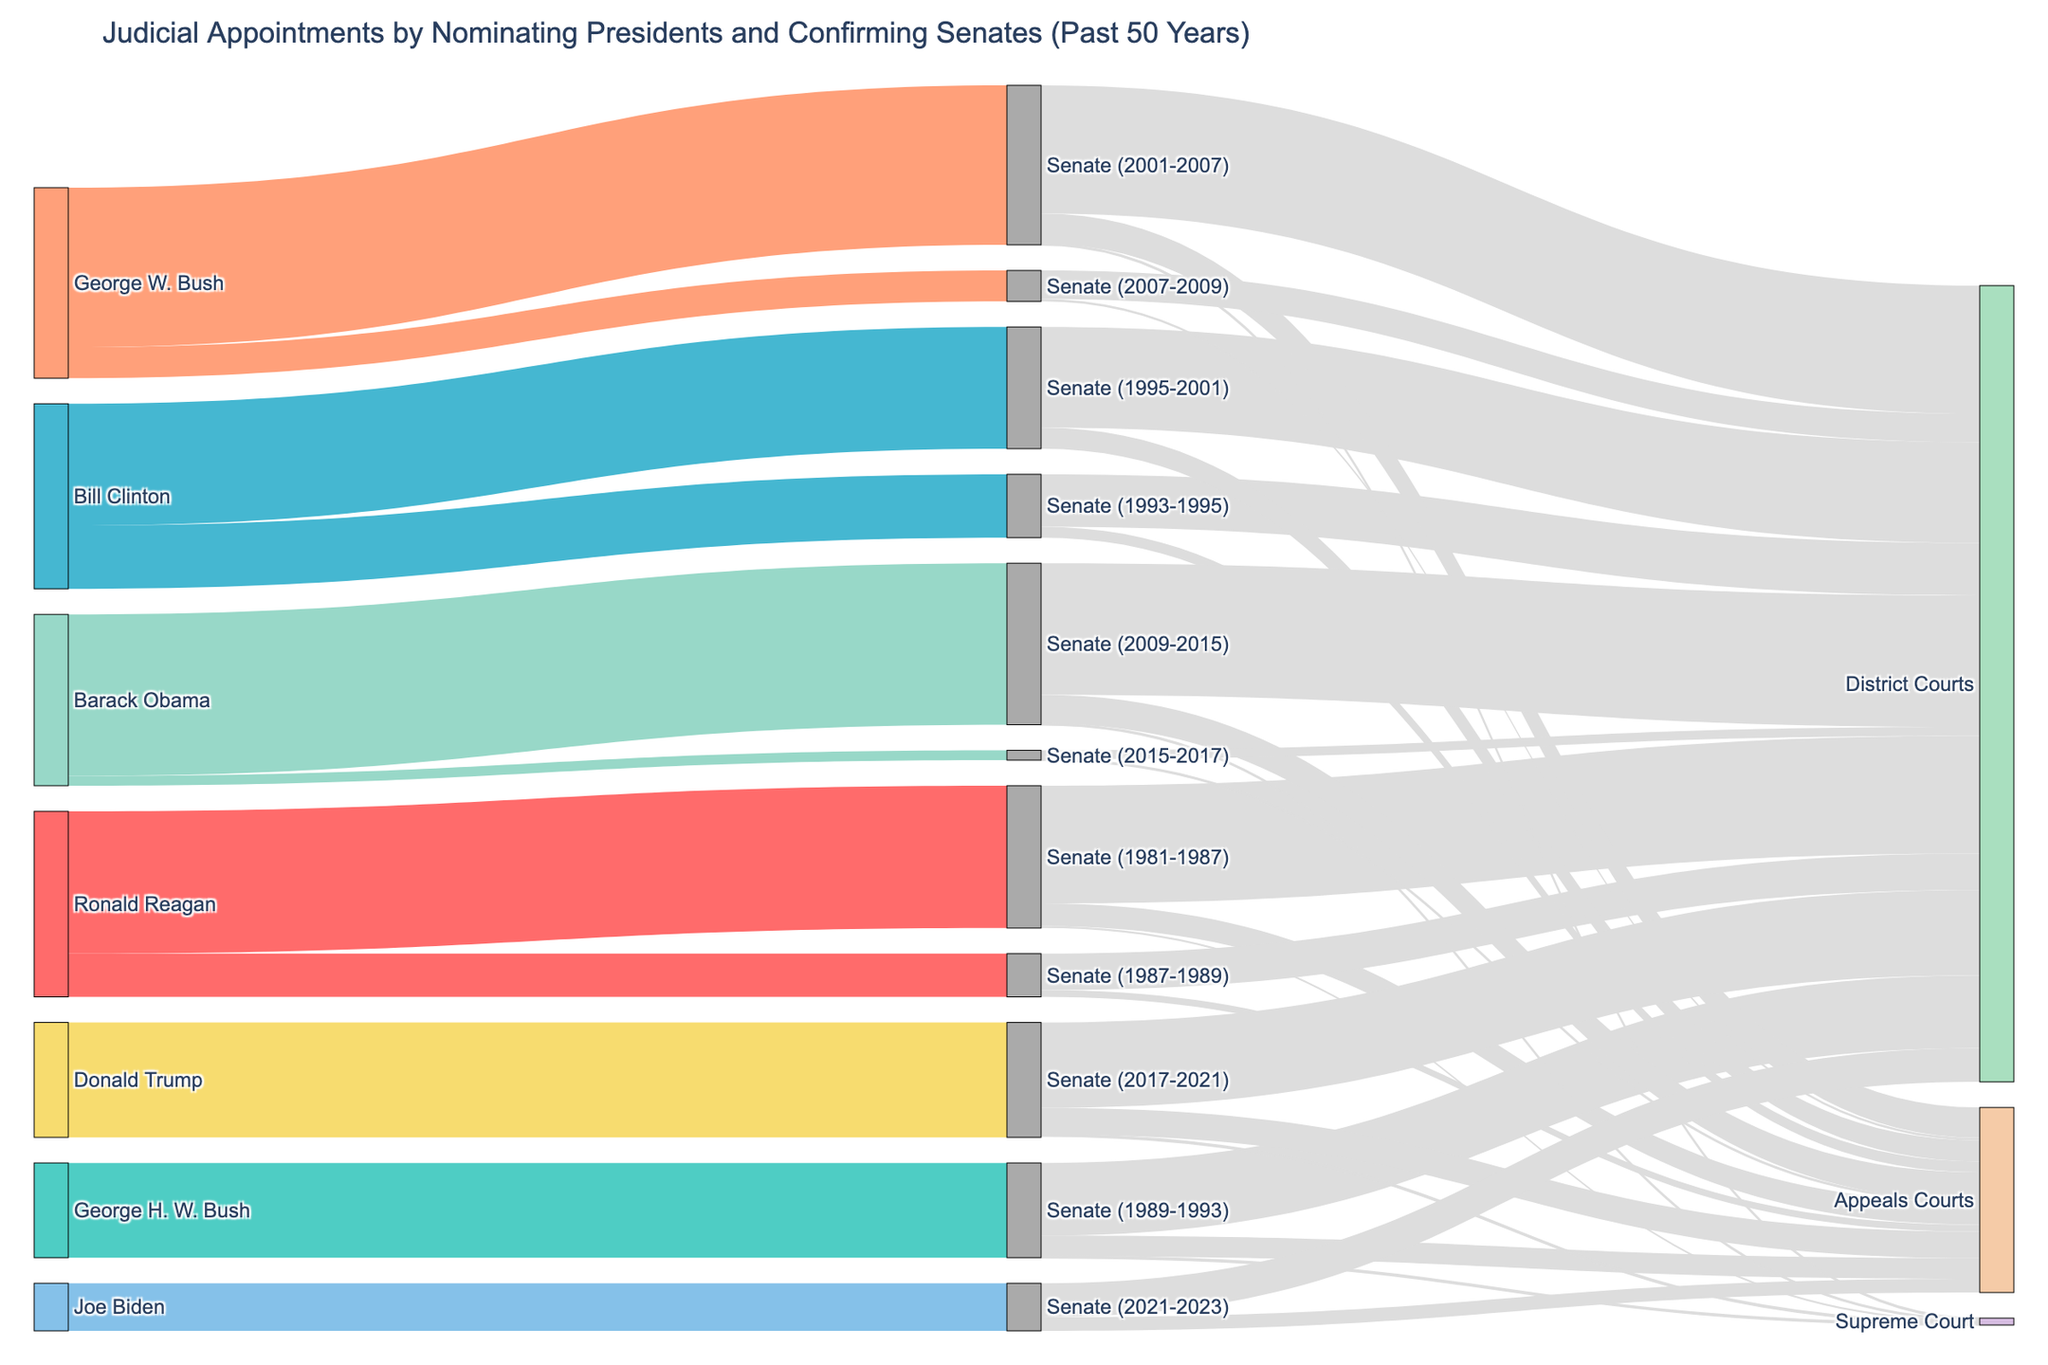Who appointed the most judges? By examining the Sankey diagram, you can trace the width of the flow from each nominating president. The wider the flow, the more judges appointed. George W. Bush has the widest flow, indicating he appointed the most judges.
Answer: George W. Bush Of the judges appointed by Ronald Reagan, how many went to the Supreme Court? Tracing Ronald Reagan’s flow to the corresponding Senate periods and subsequently to the Supreme Court section, the figure shows 4 judges appointed to the Supreme Court.
Answer: 4 Which Senate confirmed the most District Court judges? You need to compare the links from each Senate period to District Courts. The Senate in the period 2001-2007 has the widest link to District Courts, confirming 261 judges.
Answer: Senate (2001-2007) Who had the least number of judicial appointments confirmed? Compare the widths of the flows from each president. Joe Biden has the narrowest flow, indicating he had the least number of judicial appointments confirmed.
Answer: Joe Biden Which president had the highest number of judicial appointments confirmed by multiple sessions of Senate? Ronald Reagan’s and Bill Clinton’s flow branches into multiple Senate periods. To determine the highest combined total, sum the values: Ronald Reagan (290 + 88 = 378), Bill Clinton (129 + 248 = 377). Hence, Ronald Reagan had the highest combined total from multiple Senate sessions.
Answer: Ronald Reagan What is the total number of Supreme Court appointments confirmed over the past 50 years? Sum all the values leading to the Supreme Court nodes. They are 4 (1981-1987) + 3 (1989-1993) + 2 (2001-2007) + 2 (2009-2015) + 3 (2017-2021) = 14.
Answer: 14 How many more District Court judges were confirmed during Barack Obama's first Senate session compared to his second session? Barack Obama's first Senate session (2009-2015) confirmed 268 District Court judges, and the second session (2015-2017) confirmed 18. The difference is 268 - 18 = 250.
Answer: 250 Which period had the highest number of judicial appointments for Appeals Courts, and how many were confirmed? Identify the Senate period with the widest flow to Appeals Courts. The period 2001-2007 confirms the most with 62 appointments.
Answer: Senate (2001-2007), 62 Compare the number of judicial appointments confirmed by the Senate between George H. W. Bush and Donald Trump. Who had more, and what is the difference? George H. W. Bush had 193 confirmed appointments, while Donald Trump had 234. Donald Trump had 234 - 193 = 41 more appointments confirmed.
Answer: Donald Trump, 41 What is the overall number of judicial appointments that went to District Courts during George W. Bush’s presidency? Sum the values for both Senate periods during George W. Bush's presidency (2001-2007 and 2007-2009) to District Courts: 261 + 58 = 319.
Answer: 319 